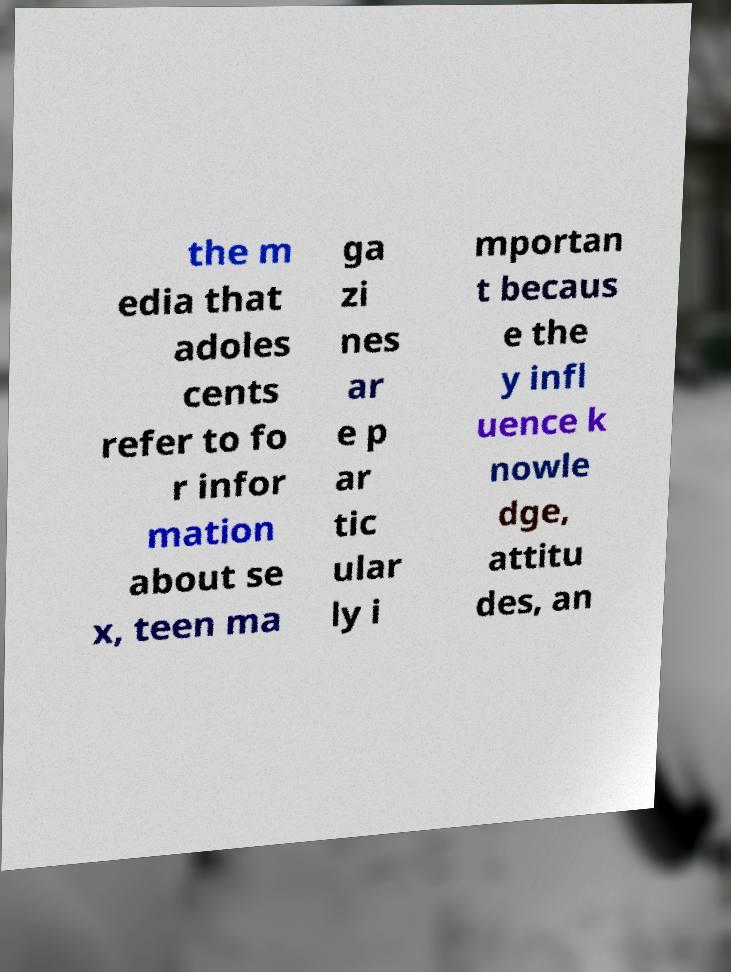For documentation purposes, I need the text within this image transcribed. Could you provide that? the m edia that adoles cents refer to fo r infor mation about se x, teen ma ga zi nes ar e p ar tic ular ly i mportan t becaus e the y infl uence k nowle dge, attitu des, an 